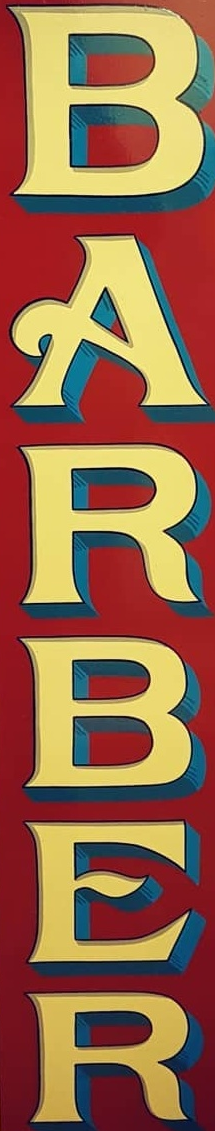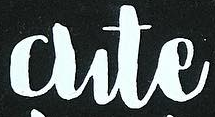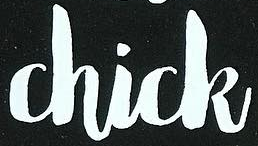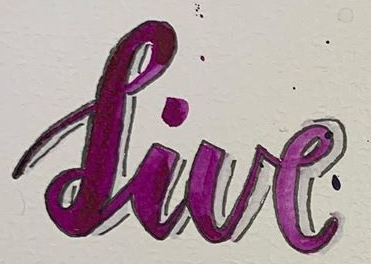What words can you see in these images in sequence, separated by a semicolon? BARBER; Cute; Chick; live 